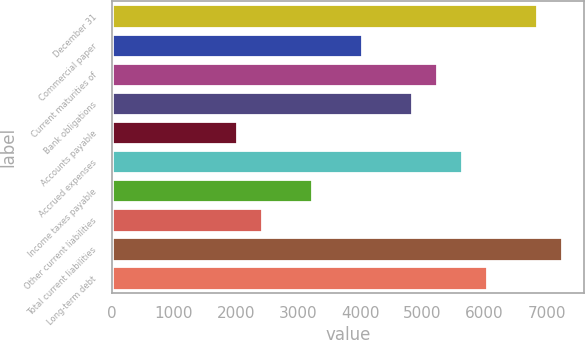<chart> <loc_0><loc_0><loc_500><loc_500><bar_chart><fcel>December 31<fcel>Commercial paper<fcel>Current maturities of<fcel>Bank obligations<fcel>Accounts payable<fcel>Accrued expenses<fcel>Income taxes payable<fcel>Other current liabilities<fcel>Total current liabilities<fcel>Long-term debt<nl><fcel>6841.8<fcel>4025<fcel>5232.2<fcel>4829.8<fcel>2013<fcel>5634.6<fcel>3220.2<fcel>2415.4<fcel>7244.2<fcel>6037<nl></chart> 